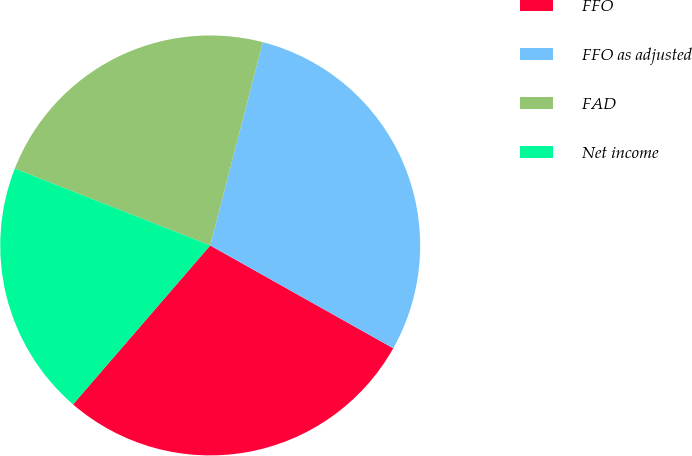<chart> <loc_0><loc_0><loc_500><loc_500><pie_chart><fcel>FFO<fcel>FFO as adjusted<fcel>FAD<fcel>Net income<nl><fcel>28.19%<fcel>29.11%<fcel>23.07%<fcel>19.63%<nl></chart> 